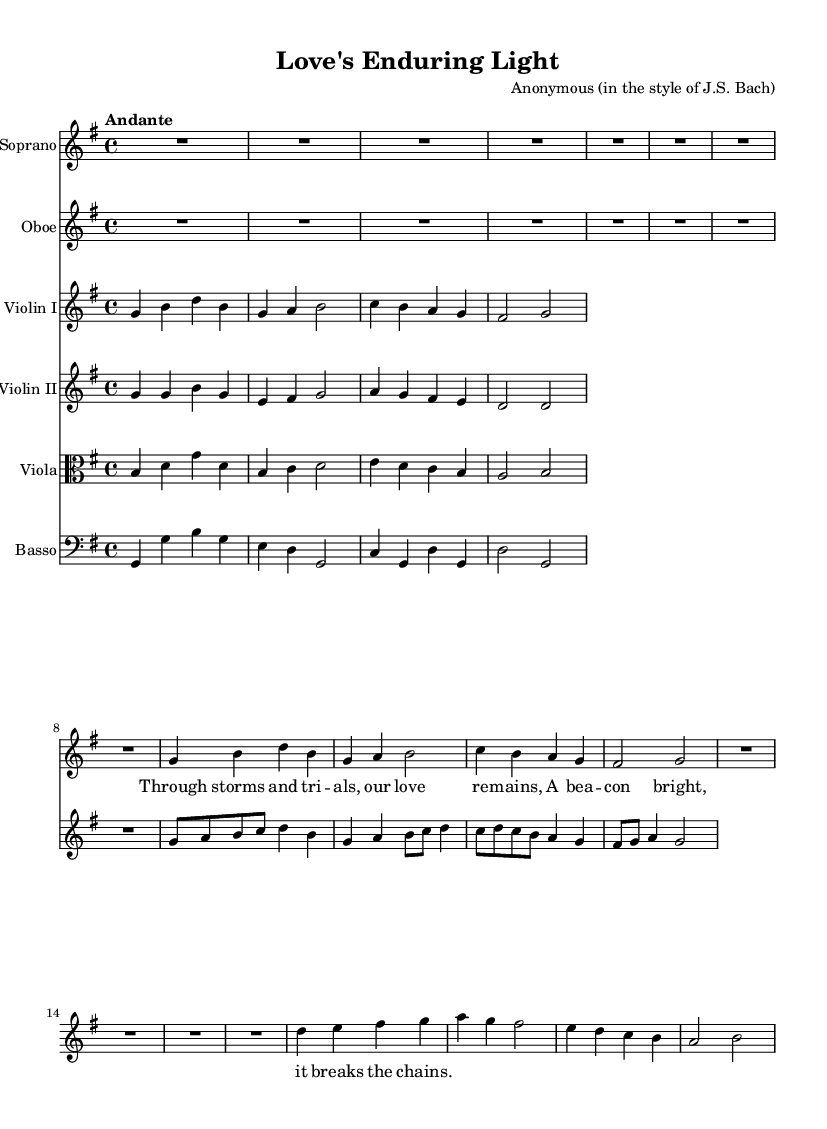What is the key signature of this music? The key signature is indicated at the beginning of the score, where it shows one sharp, which corresponds to G major.
Answer: G major What is the time signature of this piece? The time signature is found after the key signature, represented as 4/4, indicating that there are four beats in each measure and the quarter note receives one beat.
Answer: 4/4 What instrument plays the melody in this section? The soprano part is written above the others, with lyrics and more prominent notes, indicating it carries the main melodic line in this piece.
Answer: Soprano How many instruments are included in this score? By counting each staff in the score, it shows a total of six different instruments listed: Soprano, Oboe, Violin I, Violin II, Viola, and Basso.
Answer: Six What is the tempo marking of the piece? The tempo is notated underneath the key signature, where it states "Andante," which suggests a moderately slow tempo.
Answer: Andante From which era is this piece likely derived? The style of the composition, including the instrumentation and structure, suggests that this piece is derived from the Baroque era, noted for its intricate counterpoint and use of instruments.
Answer: Baroque How does the text reflect the theme of the cantata? The lyrics discuss love prevailing through challenges, which aligns with themes of endurance and commitment often found in cantatas, showcasing emotional resilience.
Answer: Endurance 